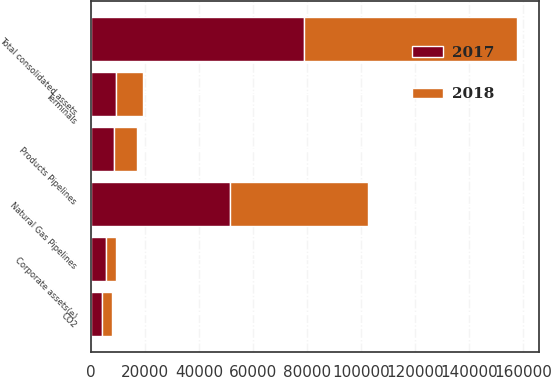Convert chart. <chart><loc_0><loc_0><loc_500><loc_500><stacked_bar_chart><ecel><fcel>Natural Gas Pipelines<fcel>Products Pipelines<fcel>Terminals<fcel>CO2<fcel>Corporate assets(e)<fcel>Total consolidated assets<nl><fcel>2017<fcel>51562<fcel>8429<fcel>9283<fcel>3928<fcel>5664<fcel>78866<nl><fcel>2018<fcel>51173<fcel>8539<fcel>9935<fcel>3946<fcel>3382<fcel>79055<nl></chart> 